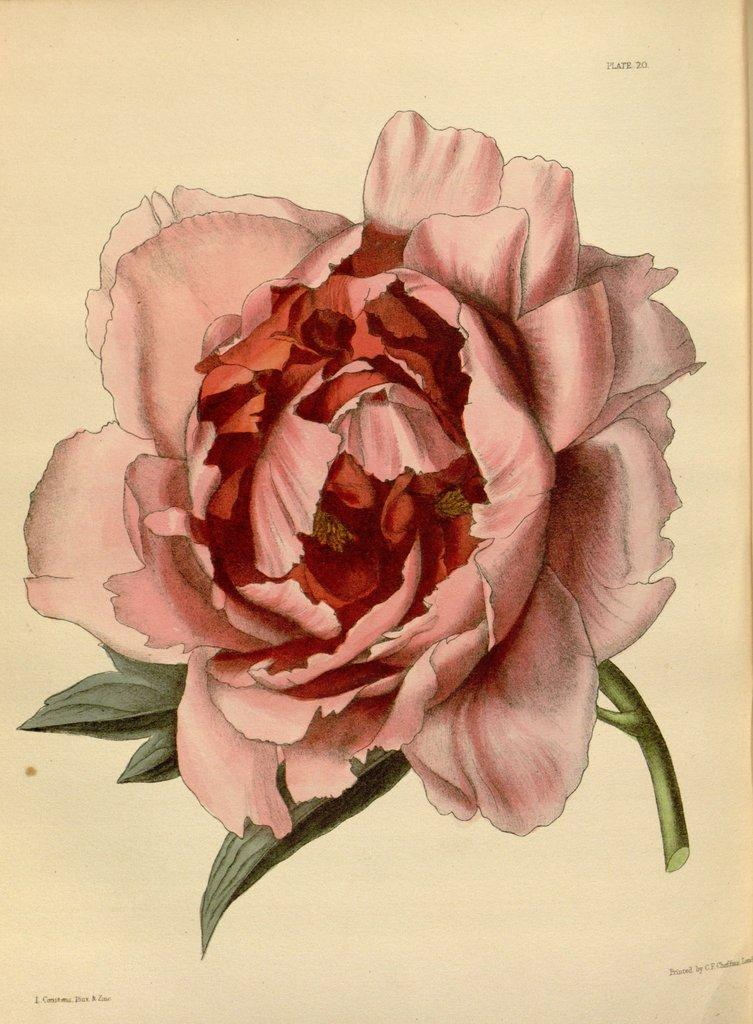What color is the flower in the image? The flower in the image is pink. What is the background of the image? The pink flower is drawn on white paper. What type of chair is depicted in the image? There is no chair present in the image; it only features a pink flower drawn on white paper. How does the wealth of the person who drew the flower affect the image? The wealth of the person who drew the flower is not mentioned or depicted in the image, so it cannot be determined how it might affect the image. 